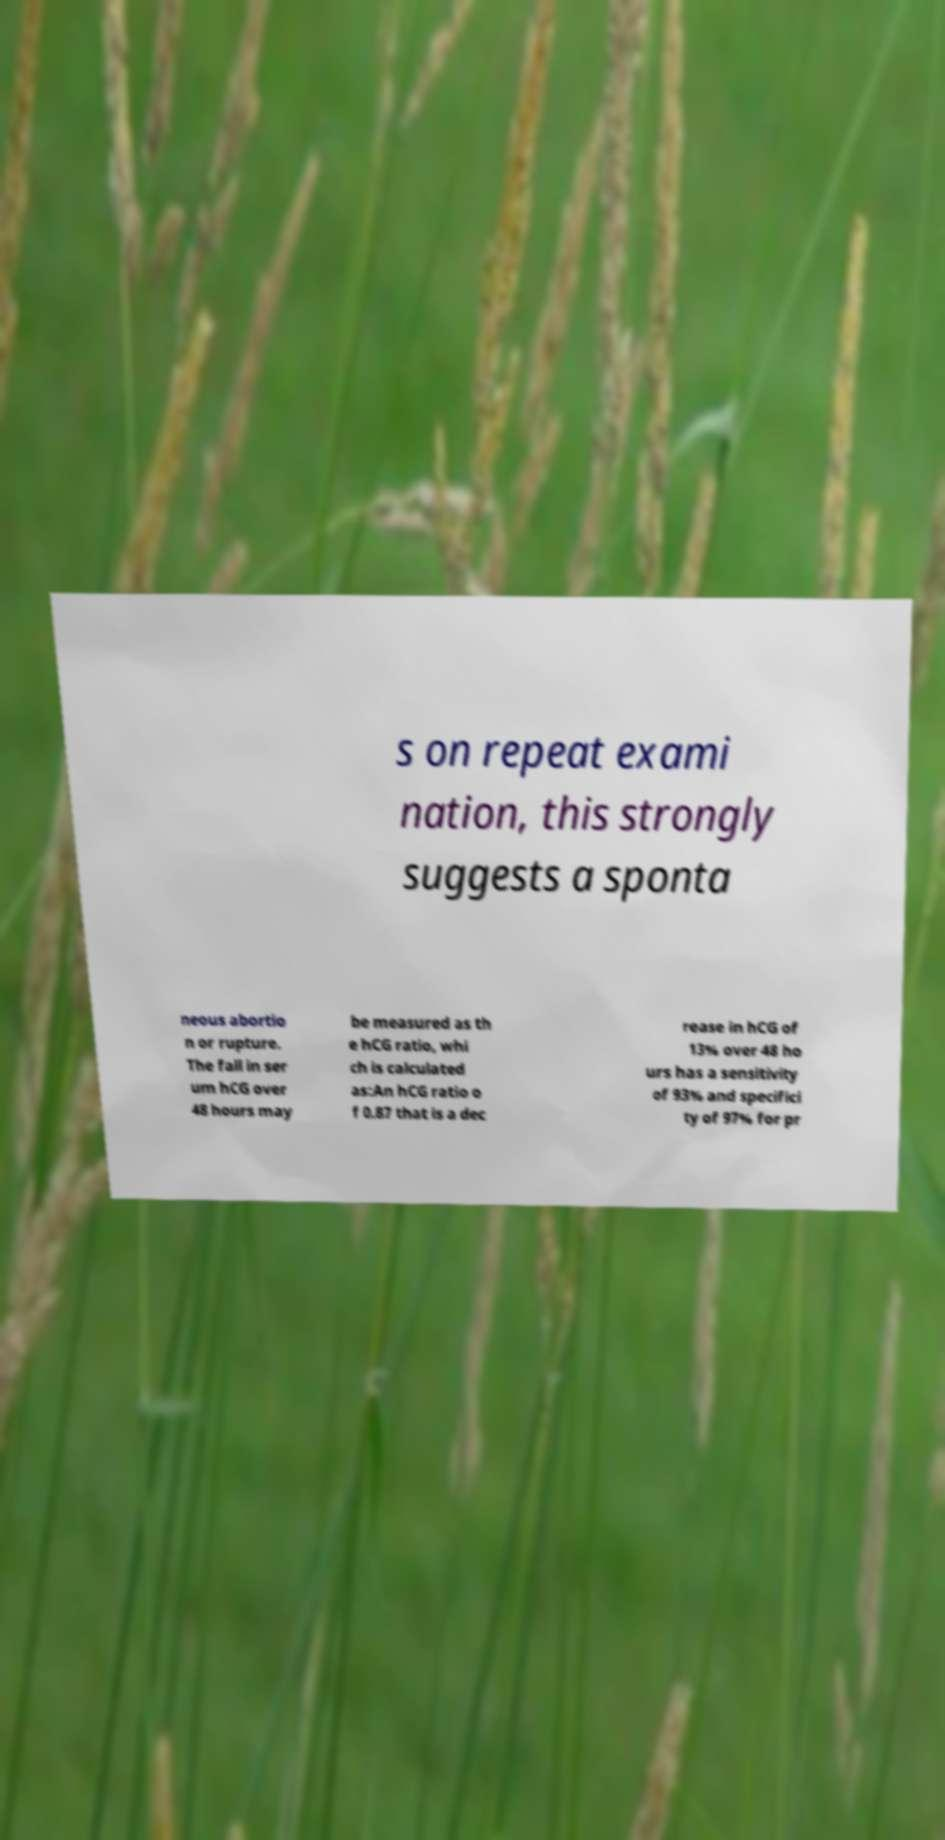I need the written content from this picture converted into text. Can you do that? s on repeat exami nation, this strongly suggests a sponta neous abortio n or rupture. The fall in ser um hCG over 48 hours may be measured as th e hCG ratio, whi ch is calculated as:An hCG ratio o f 0.87 that is a dec rease in hCG of 13% over 48 ho urs has a sensitivity of 93% and specifici ty of 97% for pr 